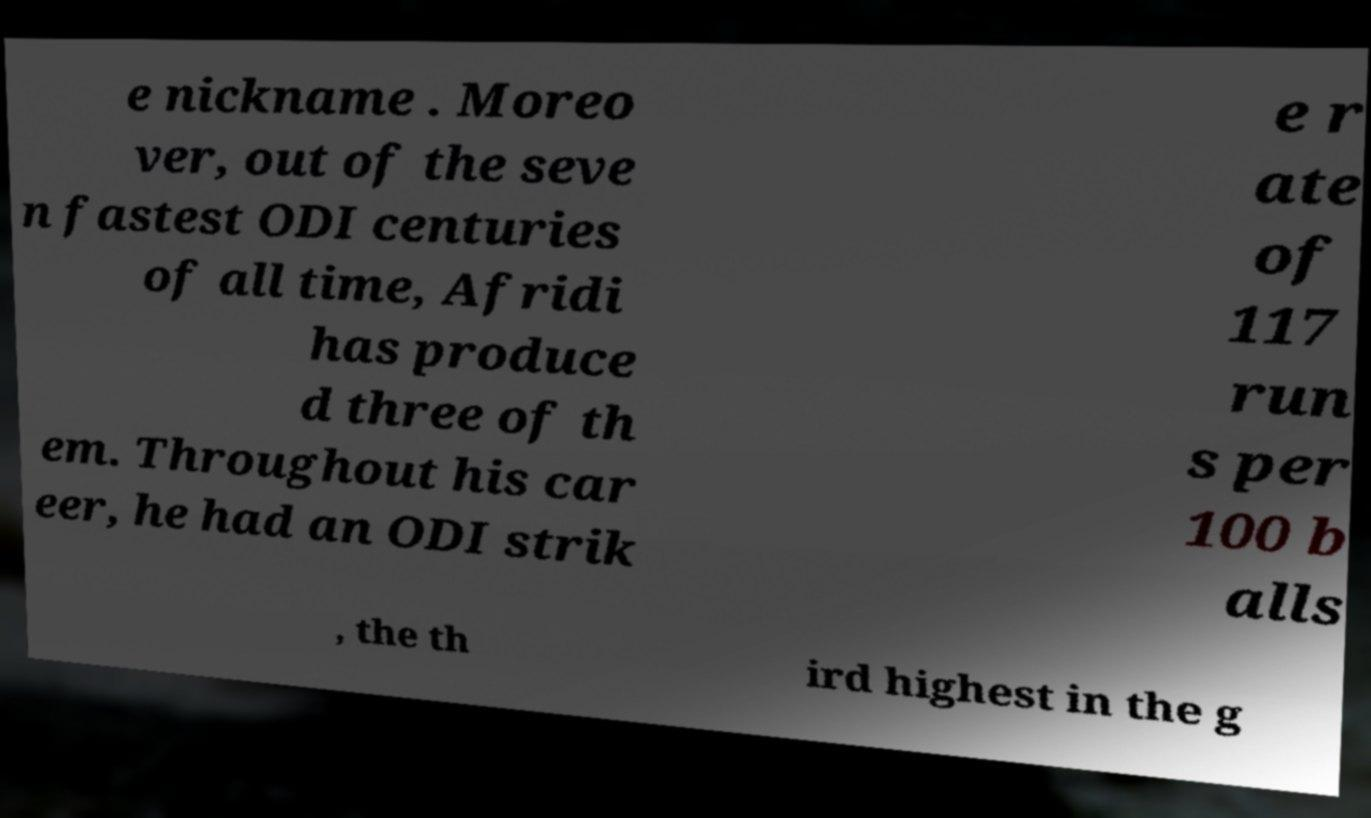For documentation purposes, I need the text within this image transcribed. Could you provide that? e nickname . Moreo ver, out of the seve n fastest ODI centuries of all time, Afridi has produce d three of th em. Throughout his car eer, he had an ODI strik e r ate of 117 run s per 100 b alls , the th ird highest in the g 